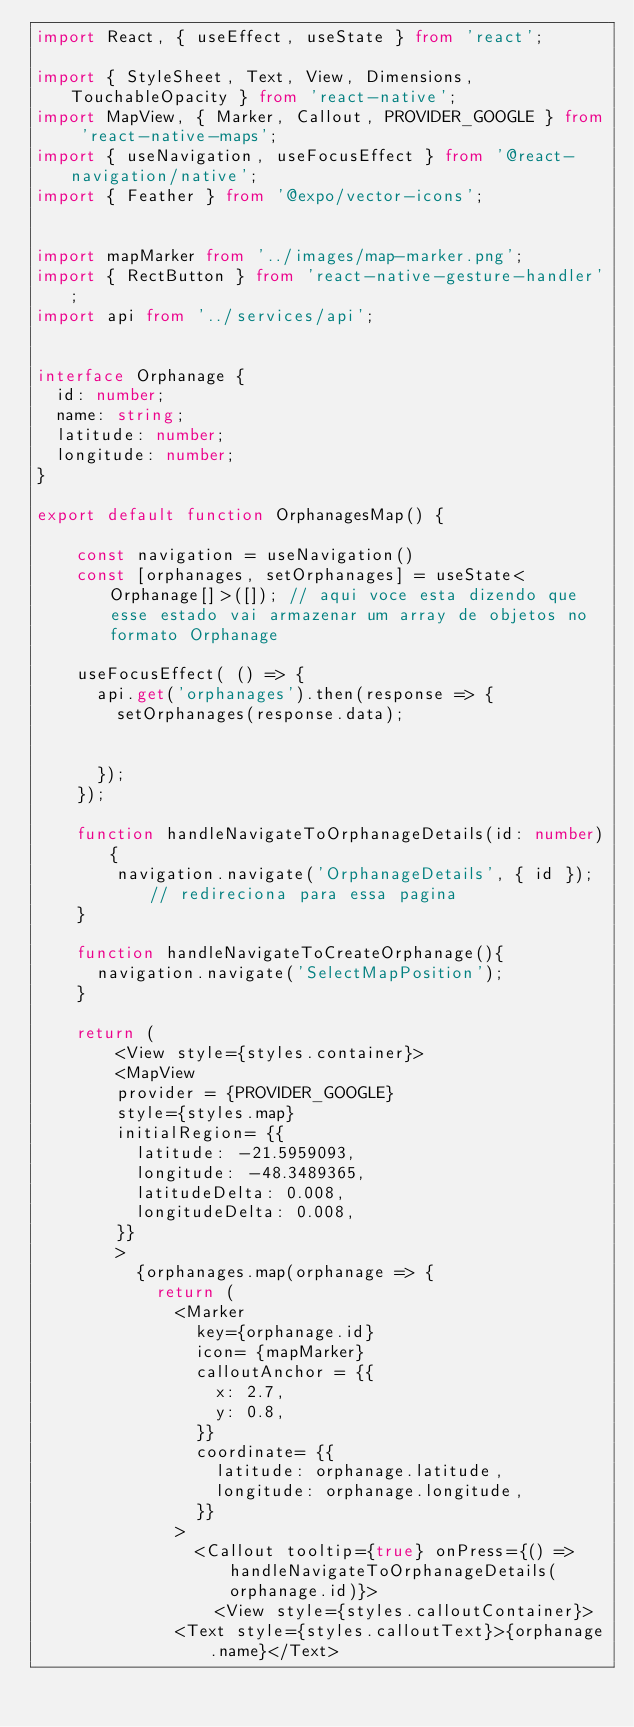Convert code to text. <code><loc_0><loc_0><loc_500><loc_500><_TypeScript_>import React, { useEffect, useState } from 'react';

import { StyleSheet, Text, View, Dimensions, TouchableOpacity } from 'react-native';
import MapView, { Marker, Callout, PROVIDER_GOOGLE } from 'react-native-maps';
import { useNavigation, useFocusEffect } from '@react-navigation/native';
import { Feather } from '@expo/vector-icons';


import mapMarker from '../images/map-marker.png';
import { RectButton } from 'react-native-gesture-handler';
import api from '../services/api';


interface Orphanage {
  id: number;
  name: string;
  latitude: number;
  longitude: number;
}

export default function OrphanagesMap() {

    const navigation = useNavigation()
    const [orphanages, setOrphanages] = useState<Orphanage[]>([]); // aqui voce esta dizendo que  esse estado vai armazenar um array de objetos no formato Orphanage

    useFocusEffect( () => {
      api.get('orphanages').then(response => {
        setOrphanages(response.data);


      });
    });

    function handleNavigateToOrphanageDetails(id: number){
        navigation.navigate('OrphanageDetails', { id }); // redireciona para essa pagina
    }
    
    function handleNavigateToCreateOrphanage(){
      navigation.navigate('SelectMapPosition');
    }

    return (
        <View style={styles.container}>
        <MapView 
        provider = {PROVIDER_GOOGLE}
        style={styles.map}
        initialRegion= {{
          latitude: -21.5959093,
          longitude: -48.3489365,
          latitudeDelta: 0.008,
          longitudeDelta: 0.008,
        }}
        >
          {orphanages.map(orphanage => {
            return (
              <Marker
                key={orphanage.id} 
                icon= {mapMarker}
                calloutAnchor = {{
                  x: 2.7,
                  y: 0.8,
                }}
                coordinate= {{
                  latitude: orphanage.latitude,
                  longitude: orphanage.longitude,
                }}
              >
                <Callout tooltip={true} onPress={() => handleNavigateToOrphanageDetails(orphanage.id)}>
                  <View style={styles.calloutContainer}>
              <Text style={styles.calloutText}>{orphanage.name}</Text></code> 